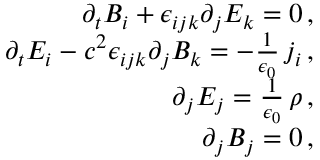<formula> <loc_0><loc_0><loc_500><loc_500>\begin{array} { r l r } & { \partial _ { t } B _ { i } + \epsilon _ { i j k } \partial _ { j } E _ { k } = 0 \, , } \\ & { \partial _ { t } E _ { i } - c ^ { 2 } \epsilon _ { i j k } \partial _ { j } B _ { k } = - \frac { 1 } { \epsilon _ { 0 } } \, j _ { i } \, , } \\ & { \partial _ { j } E _ { j } = \frac { 1 } { \epsilon _ { 0 } } \, \rho \, , } \\ & { \partial _ { j } B _ { j } = 0 \, , } \end{array}</formula> 